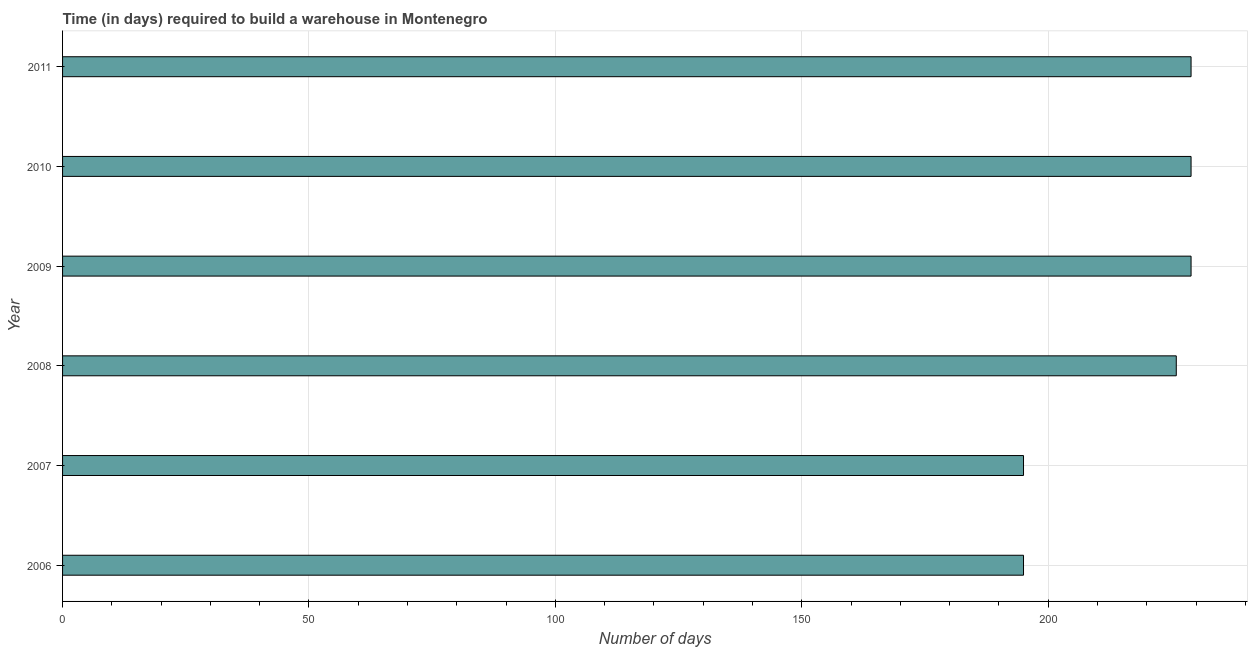Does the graph contain any zero values?
Ensure brevity in your answer.  No. Does the graph contain grids?
Your answer should be very brief. Yes. What is the title of the graph?
Make the answer very short. Time (in days) required to build a warehouse in Montenegro. What is the label or title of the X-axis?
Give a very brief answer. Number of days. What is the time required to build a warehouse in 2006?
Keep it short and to the point. 195. Across all years, what is the maximum time required to build a warehouse?
Provide a short and direct response. 229. Across all years, what is the minimum time required to build a warehouse?
Your answer should be compact. 195. In which year was the time required to build a warehouse minimum?
Offer a very short reply. 2006. What is the sum of the time required to build a warehouse?
Ensure brevity in your answer.  1303. What is the average time required to build a warehouse per year?
Keep it short and to the point. 217. What is the median time required to build a warehouse?
Your response must be concise. 227.5. Do a majority of the years between 2008 and 2011 (inclusive) have time required to build a warehouse greater than 230 days?
Keep it short and to the point. No. What is the ratio of the time required to build a warehouse in 2006 to that in 2010?
Ensure brevity in your answer.  0.85. Is the time required to build a warehouse in 2007 less than that in 2008?
Offer a very short reply. Yes. Is the sum of the time required to build a warehouse in 2008 and 2011 greater than the maximum time required to build a warehouse across all years?
Give a very brief answer. Yes. What is the difference between the highest and the lowest time required to build a warehouse?
Make the answer very short. 34. In how many years, is the time required to build a warehouse greater than the average time required to build a warehouse taken over all years?
Your answer should be very brief. 4. How many bars are there?
Give a very brief answer. 6. Are all the bars in the graph horizontal?
Provide a succinct answer. Yes. How many years are there in the graph?
Your answer should be compact. 6. What is the difference between two consecutive major ticks on the X-axis?
Provide a short and direct response. 50. What is the Number of days in 2006?
Ensure brevity in your answer.  195. What is the Number of days of 2007?
Ensure brevity in your answer.  195. What is the Number of days in 2008?
Your answer should be very brief. 226. What is the Number of days in 2009?
Provide a succinct answer. 229. What is the Number of days in 2010?
Your response must be concise. 229. What is the Number of days of 2011?
Provide a short and direct response. 229. What is the difference between the Number of days in 2006 and 2007?
Your answer should be very brief. 0. What is the difference between the Number of days in 2006 and 2008?
Give a very brief answer. -31. What is the difference between the Number of days in 2006 and 2009?
Offer a very short reply. -34. What is the difference between the Number of days in 2006 and 2010?
Provide a short and direct response. -34. What is the difference between the Number of days in 2006 and 2011?
Provide a succinct answer. -34. What is the difference between the Number of days in 2007 and 2008?
Make the answer very short. -31. What is the difference between the Number of days in 2007 and 2009?
Offer a very short reply. -34. What is the difference between the Number of days in 2007 and 2010?
Offer a very short reply. -34. What is the difference between the Number of days in 2007 and 2011?
Your answer should be very brief. -34. What is the difference between the Number of days in 2008 and 2009?
Give a very brief answer. -3. What is the difference between the Number of days in 2009 and 2010?
Make the answer very short. 0. What is the difference between the Number of days in 2009 and 2011?
Provide a short and direct response. 0. What is the ratio of the Number of days in 2006 to that in 2007?
Provide a short and direct response. 1. What is the ratio of the Number of days in 2006 to that in 2008?
Keep it short and to the point. 0.86. What is the ratio of the Number of days in 2006 to that in 2009?
Your answer should be very brief. 0.85. What is the ratio of the Number of days in 2006 to that in 2010?
Keep it short and to the point. 0.85. What is the ratio of the Number of days in 2006 to that in 2011?
Ensure brevity in your answer.  0.85. What is the ratio of the Number of days in 2007 to that in 2008?
Your answer should be very brief. 0.86. What is the ratio of the Number of days in 2007 to that in 2009?
Offer a terse response. 0.85. What is the ratio of the Number of days in 2007 to that in 2010?
Provide a short and direct response. 0.85. What is the ratio of the Number of days in 2007 to that in 2011?
Give a very brief answer. 0.85. What is the ratio of the Number of days in 2008 to that in 2009?
Your answer should be very brief. 0.99. What is the ratio of the Number of days in 2008 to that in 2010?
Make the answer very short. 0.99. What is the ratio of the Number of days in 2009 to that in 2011?
Your answer should be compact. 1. What is the ratio of the Number of days in 2010 to that in 2011?
Provide a short and direct response. 1. 